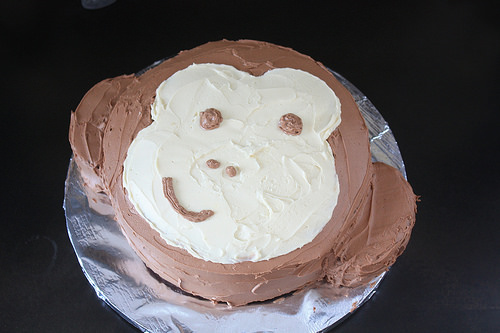<image>
Can you confirm if the smile is on the cake? Yes. Looking at the image, I can see the smile is positioned on top of the cake, with the cake providing support. 